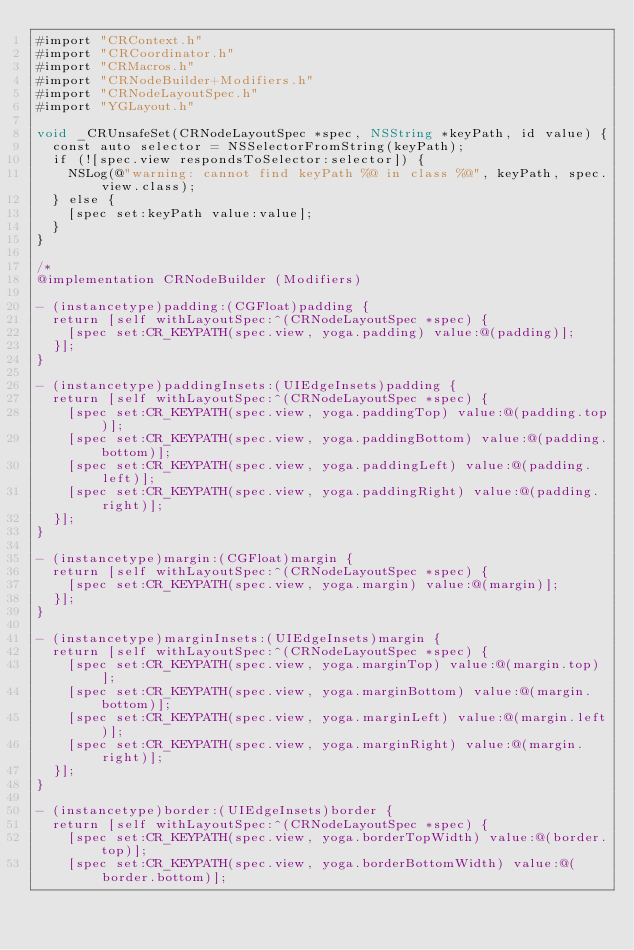<code> <loc_0><loc_0><loc_500><loc_500><_ObjectiveC_>#import "CRContext.h"
#import "CRCoordinator.h"
#import "CRMacros.h"
#import "CRNodeBuilder+Modifiers.h"
#import "CRNodeLayoutSpec.h"
#import "YGLayout.h"

void _CRUnsafeSet(CRNodeLayoutSpec *spec, NSString *keyPath, id value) {
  const auto selector = NSSelectorFromString(keyPath);
  if (![spec.view respondsToSelector:selector]) {
    NSLog(@"warning: cannot find keyPath %@ in class %@", keyPath, spec.view.class);
  } else {
    [spec set:keyPath value:value];
  }
}

/*
@implementation CRNodeBuilder (Modifiers)

- (instancetype)padding:(CGFloat)padding {
  return [self withLayoutSpec:^(CRNodeLayoutSpec *spec) {
    [spec set:CR_KEYPATH(spec.view, yoga.padding) value:@(padding)];
  }];
}

- (instancetype)paddingInsets:(UIEdgeInsets)padding {
  return [self withLayoutSpec:^(CRNodeLayoutSpec *spec) {
    [spec set:CR_KEYPATH(spec.view, yoga.paddingTop) value:@(padding.top)];
    [spec set:CR_KEYPATH(spec.view, yoga.paddingBottom) value:@(padding.bottom)];
    [spec set:CR_KEYPATH(spec.view, yoga.paddingLeft) value:@(padding.left)];
    [spec set:CR_KEYPATH(spec.view, yoga.paddingRight) value:@(padding.right)];
  }];
}

- (instancetype)margin:(CGFloat)margin {
  return [self withLayoutSpec:^(CRNodeLayoutSpec *spec) {
    [spec set:CR_KEYPATH(spec.view, yoga.margin) value:@(margin)];
  }];
}

- (instancetype)marginInsets:(UIEdgeInsets)margin {
  return [self withLayoutSpec:^(CRNodeLayoutSpec *spec) {
    [spec set:CR_KEYPATH(spec.view, yoga.marginTop) value:@(margin.top)];
    [spec set:CR_KEYPATH(spec.view, yoga.marginBottom) value:@(margin.bottom)];
    [spec set:CR_KEYPATH(spec.view, yoga.marginLeft) value:@(margin.left)];
    [spec set:CR_KEYPATH(spec.view, yoga.marginRight) value:@(margin.right)];
  }];
}

- (instancetype)border:(UIEdgeInsets)border {
  return [self withLayoutSpec:^(CRNodeLayoutSpec *spec) {
    [spec set:CR_KEYPATH(spec.view, yoga.borderTopWidth) value:@(border.top)];
    [spec set:CR_KEYPATH(spec.view, yoga.borderBottomWidth) value:@(border.bottom)];</code> 